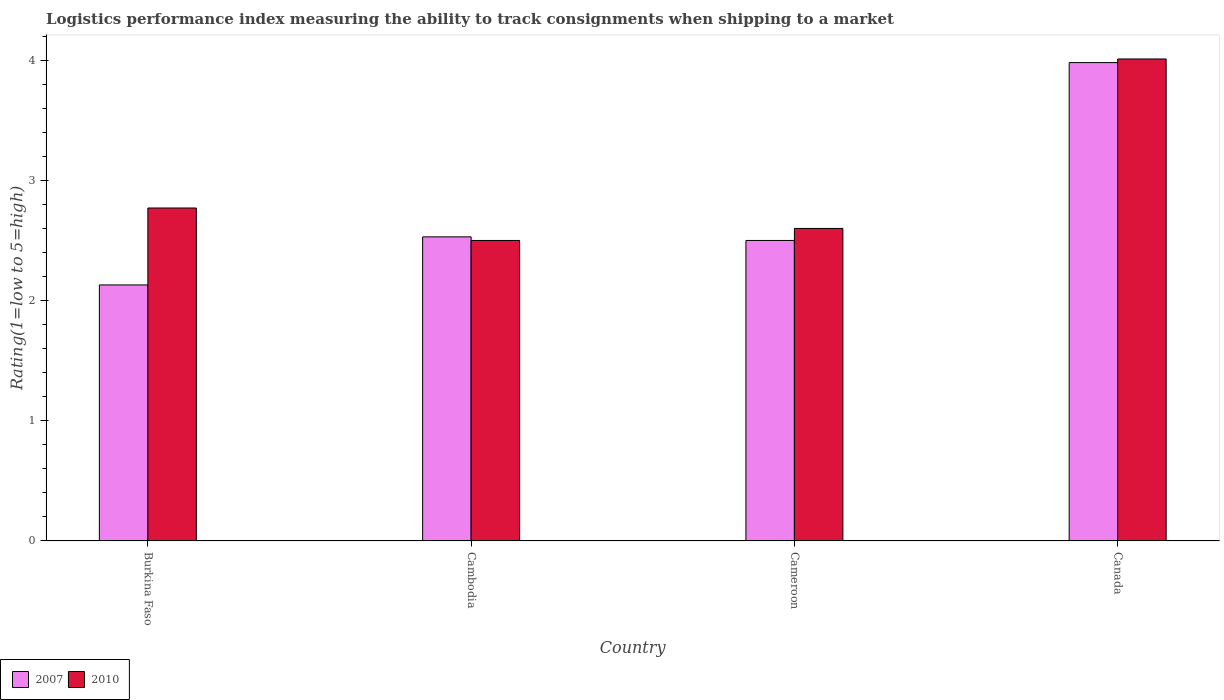How many different coloured bars are there?
Provide a succinct answer. 2. Are the number of bars per tick equal to the number of legend labels?
Offer a terse response. Yes. Are the number of bars on each tick of the X-axis equal?
Offer a very short reply. Yes. How many bars are there on the 2nd tick from the left?
Ensure brevity in your answer.  2. How many bars are there on the 3rd tick from the right?
Keep it short and to the point. 2. What is the label of the 2nd group of bars from the left?
Ensure brevity in your answer.  Cambodia. What is the Logistic performance index in 2007 in Cameroon?
Give a very brief answer. 2.5. Across all countries, what is the maximum Logistic performance index in 2007?
Your answer should be very brief. 3.98. Across all countries, what is the minimum Logistic performance index in 2010?
Your answer should be compact. 2.5. In which country was the Logistic performance index in 2007 minimum?
Keep it short and to the point. Burkina Faso. What is the total Logistic performance index in 2010 in the graph?
Make the answer very short. 11.88. What is the difference between the Logistic performance index in 2010 in Burkina Faso and that in Cameroon?
Provide a succinct answer. 0.17. What is the difference between the Logistic performance index in 2007 in Cambodia and the Logistic performance index in 2010 in Cameroon?
Ensure brevity in your answer.  -0.07. What is the average Logistic performance index in 2010 per country?
Give a very brief answer. 2.97. What is the difference between the Logistic performance index of/in 2010 and Logistic performance index of/in 2007 in Cambodia?
Your answer should be very brief. -0.03. What is the ratio of the Logistic performance index in 2010 in Cameroon to that in Canada?
Ensure brevity in your answer.  0.65. Is the Logistic performance index in 2007 in Burkina Faso less than that in Cambodia?
Provide a short and direct response. Yes. What is the difference between the highest and the second highest Logistic performance index in 2010?
Provide a short and direct response. 0.17. What is the difference between the highest and the lowest Logistic performance index in 2010?
Offer a very short reply. 1.51. In how many countries, is the Logistic performance index in 2010 greater than the average Logistic performance index in 2010 taken over all countries?
Your response must be concise. 1. How many bars are there?
Offer a very short reply. 8. Are all the bars in the graph horizontal?
Keep it short and to the point. No. How many countries are there in the graph?
Provide a succinct answer. 4. What is the difference between two consecutive major ticks on the Y-axis?
Keep it short and to the point. 1. Are the values on the major ticks of Y-axis written in scientific E-notation?
Your answer should be compact. No. Does the graph contain grids?
Keep it short and to the point. No. How many legend labels are there?
Offer a terse response. 2. What is the title of the graph?
Offer a terse response. Logistics performance index measuring the ability to track consignments when shipping to a market. Does "2010" appear as one of the legend labels in the graph?
Your response must be concise. Yes. What is the label or title of the X-axis?
Your answer should be compact. Country. What is the label or title of the Y-axis?
Give a very brief answer. Rating(1=low to 5=high). What is the Rating(1=low to 5=high) in 2007 in Burkina Faso?
Give a very brief answer. 2.13. What is the Rating(1=low to 5=high) of 2010 in Burkina Faso?
Provide a succinct answer. 2.77. What is the Rating(1=low to 5=high) in 2007 in Cambodia?
Provide a succinct answer. 2.53. What is the Rating(1=low to 5=high) of 2007 in Cameroon?
Your answer should be compact. 2.5. What is the Rating(1=low to 5=high) of 2007 in Canada?
Make the answer very short. 3.98. What is the Rating(1=low to 5=high) of 2010 in Canada?
Your answer should be very brief. 4.01. Across all countries, what is the maximum Rating(1=low to 5=high) of 2007?
Your answer should be compact. 3.98. Across all countries, what is the maximum Rating(1=low to 5=high) of 2010?
Offer a very short reply. 4.01. Across all countries, what is the minimum Rating(1=low to 5=high) of 2007?
Ensure brevity in your answer.  2.13. Across all countries, what is the minimum Rating(1=low to 5=high) in 2010?
Keep it short and to the point. 2.5. What is the total Rating(1=low to 5=high) of 2007 in the graph?
Give a very brief answer. 11.14. What is the total Rating(1=low to 5=high) of 2010 in the graph?
Your answer should be compact. 11.88. What is the difference between the Rating(1=low to 5=high) in 2007 in Burkina Faso and that in Cambodia?
Keep it short and to the point. -0.4. What is the difference between the Rating(1=low to 5=high) in 2010 in Burkina Faso and that in Cambodia?
Make the answer very short. 0.27. What is the difference between the Rating(1=low to 5=high) in 2007 in Burkina Faso and that in Cameroon?
Your response must be concise. -0.37. What is the difference between the Rating(1=low to 5=high) of 2010 in Burkina Faso and that in Cameroon?
Your answer should be compact. 0.17. What is the difference between the Rating(1=low to 5=high) of 2007 in Burkina Faso and that in Canada?
Make the answer very short. -1.85. What is the difference between the Rating(1=low to 5=high) of 2010 in Burkina Faso and that in Canada?
Give a very brief answer. -1.24. What is the difference between the Rating(1=low to 5=high) of 2010 in Cambodia and that in Cameroon?
Provide a succinct answer. -0.1. What is the difference between the Rating(1=low to 5=high) in 2007 in Cambodia and that in Canada?
Provide a succinct answer. -1.45. What is the difference between the Rating(1=low to 5=high) in 2010 in Cambodia and that in Canada?
Make the answer very short. -1.51. What is the difference between the Rating(1=low to 5=high) in 2007 in Cameroon and that in Canada?
Provide a succinct answer. -1.48. What is the difference between the Rating(1=low to 5=high) in 2010 in Cameroon and that in Canada?
Your answer should be compact. -1.41. What is the difference between the Rating(1=low to 5=high) of 2007 in Burkina Faso and the Rating(1=low to 5=high) of 2010 in Cambodia?
Ensure brevity in your answer.  -0.37. What is the difference between the Rating(1=low to 5=high) of 2007 in Burkina Faso and the Rating(1=low to 5=high) of 2010 in Cameroon?
Your response must be concise. -0.47. What is the difference between the Rating(1=low to 5=high) of 2007 in Burkina Faso and the Rating(1=low to 5=high) of 2010 in Canada?
Your answer should be compact. -1.88. What is the difference between the Rating(1=low to 5=high) of 2007 in Cambodia and the Rating(1=low to 5=high) of 2010 in Cameroon?
Keep it short and to the point. -0.07. What is the difference between the Rating(1=low to 5=high) of 2007 in Cambodia and the Rating(1=low to 5=high) of 2010 in Canada?
Keep it short and to the point. -1.48. What is the difference between the Rating(1=low to 5=high) of 2007 in Cameroon and the Rating(1=low to 5=high) of 2010 in Canada?
Offer a terse response. -1.51. What is the average Rating(1=low to 5=high) in 2007 per country?
Give a very brief answer. 2.79. What is the average Rating(1=low to 5=high) of 2010 per country?
Provide a short and direct response. 2.97. What is the difference between the Rating(1=low to 5=high) in 2007 and Rating(1=low to 5=high) in 2010 in Burkina Faso?
Keep it short and to the point. -0.64. What is the difference between the Rating(1=low to 5=high) in 2007 and Rating(1=low to 5=high) in 2010 in Cameroon?
Your response must be concise. -0.1. What is the difference between the Rating(1=low to 5=high) of 2007 and Rating(1=low to 5=high) of 2010 in Canada?
Your response must be concise. -0.03. What is the ratio of the Rating(1=low to 5=high) of 2007 in Burkina Faso to that in Cambodia?
Provide a succinct answer. 0.84. What is the ratio of the Rating(1=low to 5=high) of 2010 in Burkina Faso to that in Cambodia?
Offer a terse response. 1.11. What is the ratio of the Rating(1=low to 5=high) of 2007 in Burkina Faso to that in Cameroon?
Keep it short and to the point. 0.85. What is the ratio of the Rating(1=low to 5=high) in 2010 in Burkina Faso to that in Cameroon?
Ensure brevity in your answer.  1.07. What is the ratio of the Rating(1=low to 5=high) of 2007 in Burkina Faso to that in Canada?
Provide a succinct answer. 0.54. What is the ratio of the Rating(1=low to 5=high) of 2010 in Burkina Faso to that in Canada?
Your response must be concise. 0.69. What is the ratio of the Rating(1=low to 5=high) in 2007 in Cambodia to that in Cameroon?
Your answer should be very brief. 1.01. What is the ratio of the Rating(1=low to 5=high) in 2010 in Cambodia to that in Cameroon?
Give a very brief answer. 0.96. What is the ratio of the Rating(1=low to 5=high) in 2007 in Cambodia to that in Canada?
Offer a terse response. 0.64. What is the ratio of the Rating(1=low to 5=high) of 2010 in Cambodia to that in Canada?
Provide a succinct answer. 0.62. What is the ratio of the Rating(1=low to 5=high) of 2007 in Cameroon to that in Canada?
Make the answer very short. 0.63. What is the ratio of the Rating(1=low to 5=high) in 2010 in Cameroon to that in Canada?
Your response must be concise. 0.65. What is the difference between the highest and the second highest Rating(1=low to 5=high) of 2007?
Your response must be concise. 1.45. What is the difference between the highest and the second highest Rating(1=low to 5=high) in 2010?
Offer a very short reply. 1.24. What is the difference between the highest and the lowest Rating(1=low to 5=high) in 2007?
Make the answer very short. 1.85. What is the difference between the highest and the lowest Rating(1=low to 5=high) of 2010?
Make the answer very short. 1.51. 